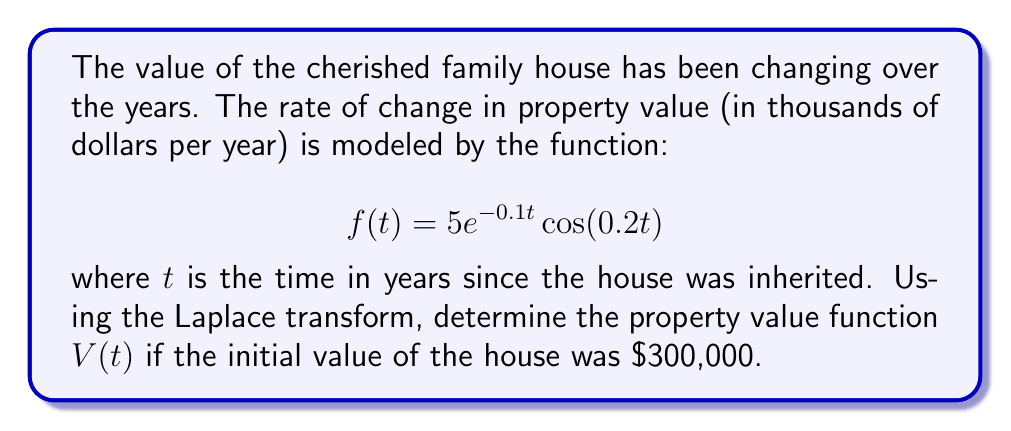Provide a solution to this math problem. To solve this problem, we'll use the Laplace transform method:

1) First, let's define the Laplace transform of $V(t)$ as $F(s)$:
   $$\mathcal{L}\{V(t)\} = F(s)$$

2) We know that $f(t)$ represents the rate of change of $V(t)$, so:
   $$f(t) = \frac{dV}{dt}$$

3) Taking the Laplace transform of both sides:
   $$\mathcal{L}\{f(t)\} = \mathcal{L}\{\frac{dV}{dt}\}$$

4) Using the property of Laplace transform for derivatives:
   $$\mathcal{L}\{f(t)\} = sF(s) - V(0)$$

5) We're given that $V(0) = 300$ (in thousands of dollars)

6) Now, let's find $\mathcal{L}\{f(t)\}$:
   $$\mathcal{L}\{5e^{-0.1t} \cos(0.2t)\} = \frac{5s + 0.5}{(s + 0.1)^2 + 0.04}$$

7) Equating steps 4 and 6:
   $$\frac{5s + 0.5}{(s + 0.1)^2 + 0.04} = sF(s) - 300$$

8) Solving for $F(s)$:
   $$F(s) = \frac{5s + 0.5}{s((s + 0.1)^2 + 0.04)} + \frac{300}{s}$$

9) Decomposing into partial fractions:
   $$F(s) = \frac{300}{s} + \frac{5}{(s + 0.1)^2 + 0.04} + \frac{0.5}{s((s + 0.1)^2 + 0.04)}$$

10) Taking the inverse Laplace transform:
    $$V(t) = 300 + 25e^{-0.1t}\cos(0.2t) + 2.5e^{-0.1t}\sin(0.2t)$$

This gives us the property value function $V(t)$ in thousands of dollars.
Answer: $V(t) = 300 + 25e^{-0.1t}\cos(0.2t) + 2.5e^{-0.1t}\sin(0.2t)$ (in thousands of dollars) 